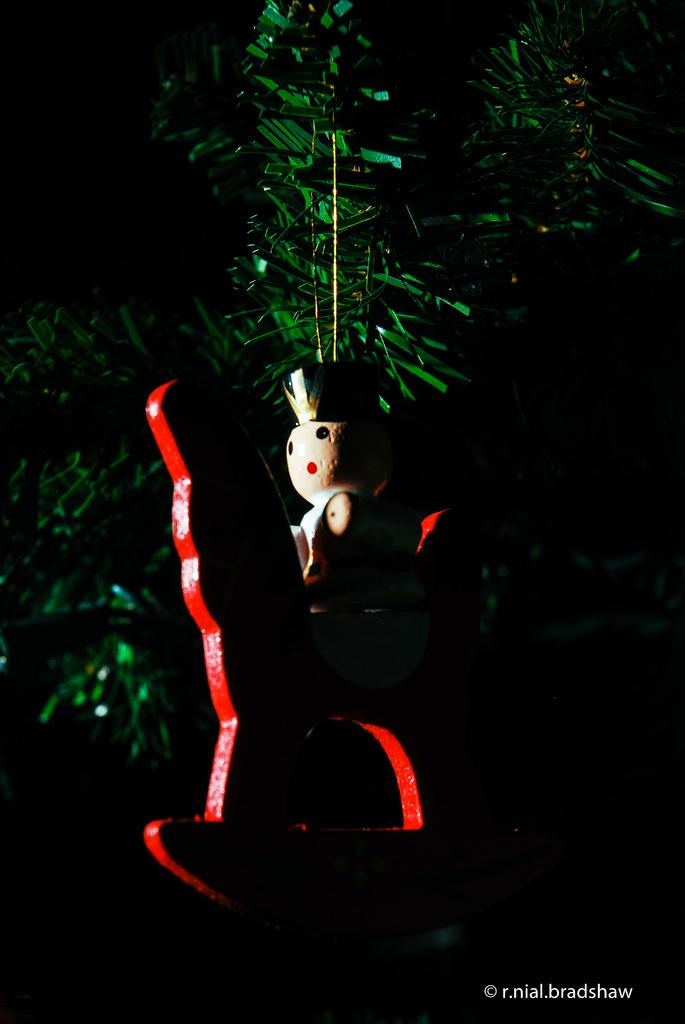What object can be seen in the image? There is a toy in the image. What can be found in the background of the image? There are plastic leaves in the background of the image. Where is the hen located in the image? There is no hen present in the image. What type of transportation can be seen at the airport in the image? There is no airport present in the image. How many wheels are visible on the toy in the image? The provided facts do not mention the number of wheels on the toy, so we cannot definitively answer this question. 